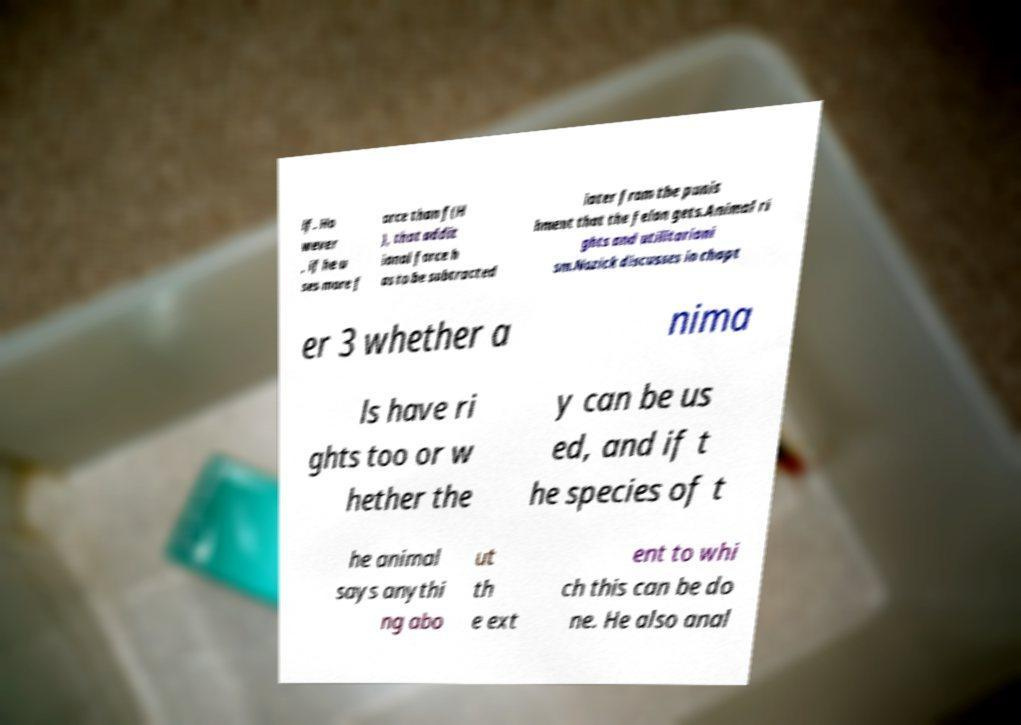I need the written content from this picture converted into text. Can you do that? lf. Ho wever , if he u ses more f orce than f(H ), that addit ional force h as to be subtracted later from the punis hment that the felon gets.Animal ri ghts and utilitariani sm.Nozick discusses in chapt er 3 whether a nima ls have ri ghts too or w hether the y can be us ed, and if t he species of t he animal says anythi ng abo ut th e ext ent to whi ch this can be do ne. He also anal 